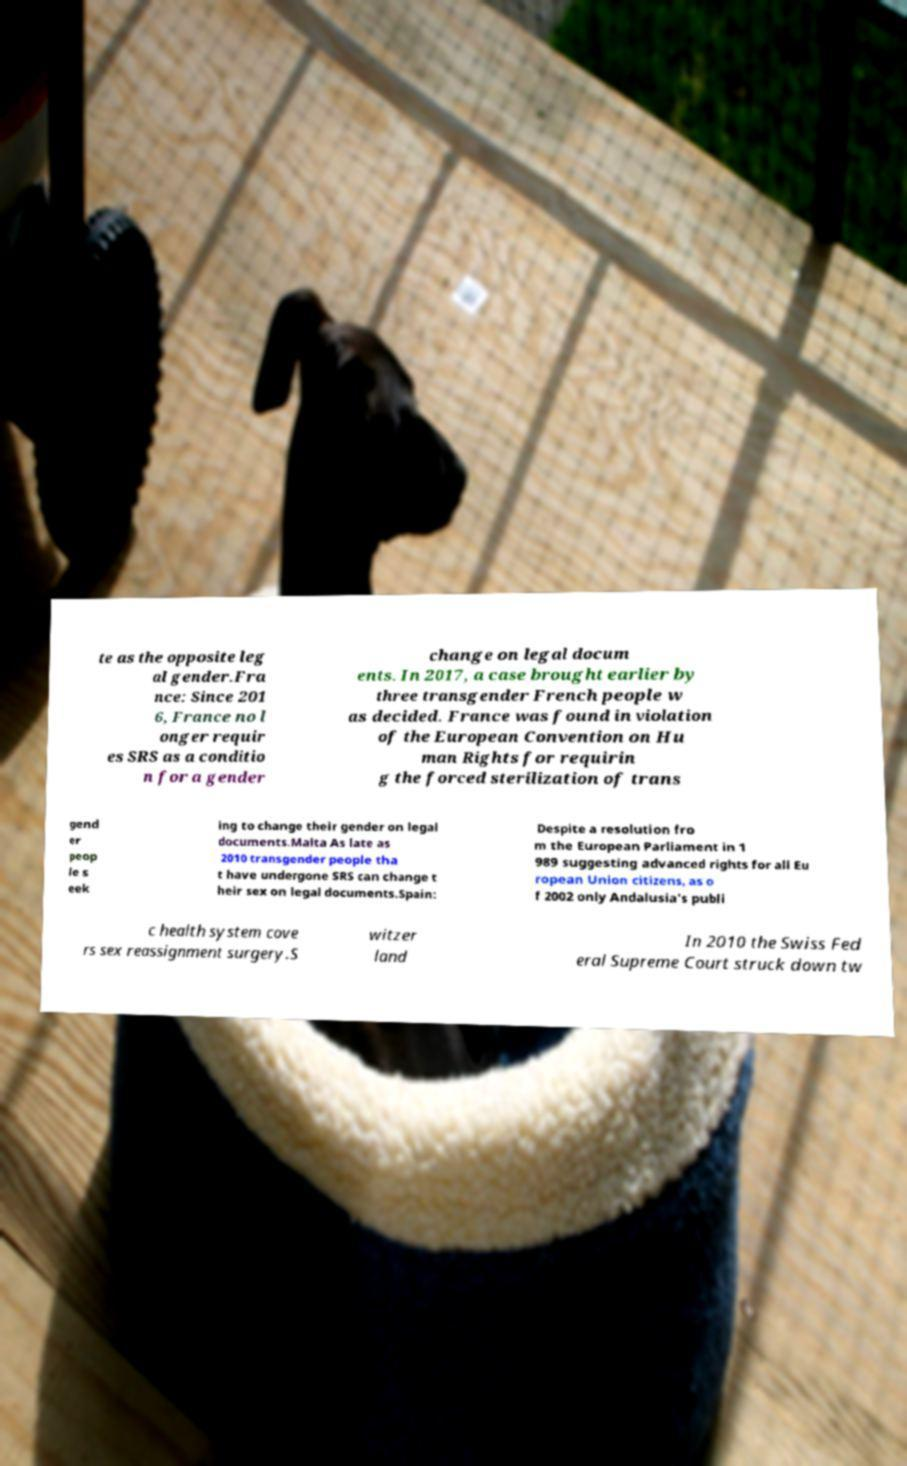Could you assist in decoding the text presented in this image and type it out clearly? te as the opposite leg al gender.Fra nce: Since 201 6, France no l onger requir es SRS as a conditio n for a gender change on legal docum ents. In 2017, a case brought earlier by three transgender French people w as decided. France was found in violation of the European Convention on Hu man Rights for requirin g the forced sterilization of trans gend er peop le s eek ing to change their gender on legal documents.Malta As late as 2010 transgender people tha t have undergone SRS can change t heir sex on legal documents.Spain: Despite a resolution fro m the European Parliament in 1 989 suggesting advanced rights for all Eu ropean Union citizens, as o f 2002 only Andalusia's publi c health system cove rs sex reassignment surgery.S witzer land In 2010 the Swiss Fed eral Supreme Court struck down tw 